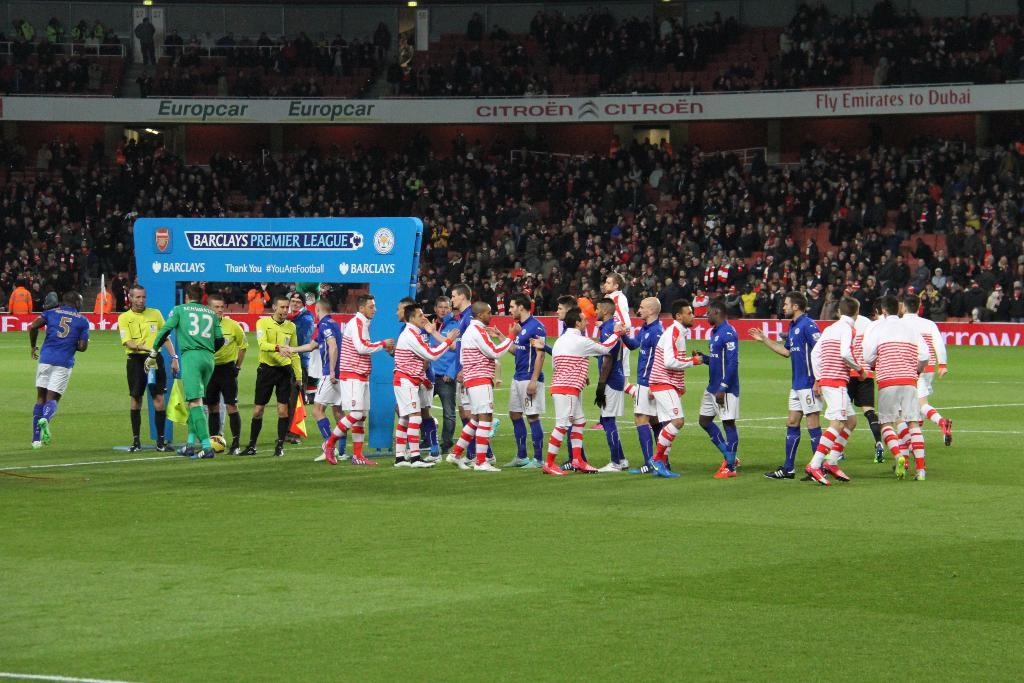Provide a one-sentence caption for the provided image. Premier League players from different teams shake hands and high five each other. 